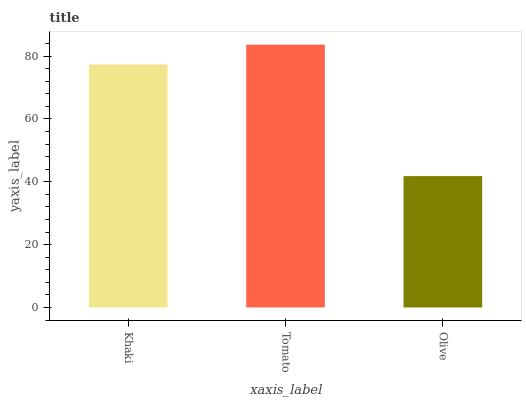Is Olive the minimum?
Answer yes or no. Yes. Is Tomato the maximum?
Answer yes or no. Yes. Is Tomato the minimum?
Answer yes or no. No. Is Olive the maximum?
Answer yes or no. No. Is Tomato greater than Olive?
Answer yes or no. Yes. Is Olive less than Tomato?
Answer yes or no. Yes. Is Olive greater than Tomato?
Answer yes or no. No. Is Tomato less than Olive?
Answer yes or no. No. Is Khaki the high median?
Answer yes or no. Yes. Is Khaki the low median?
Answer yes or no. Yes. Is Tomato the high median?
Answer yes or no. No. Is Tomato the low median?
Answer yes or no. No. 